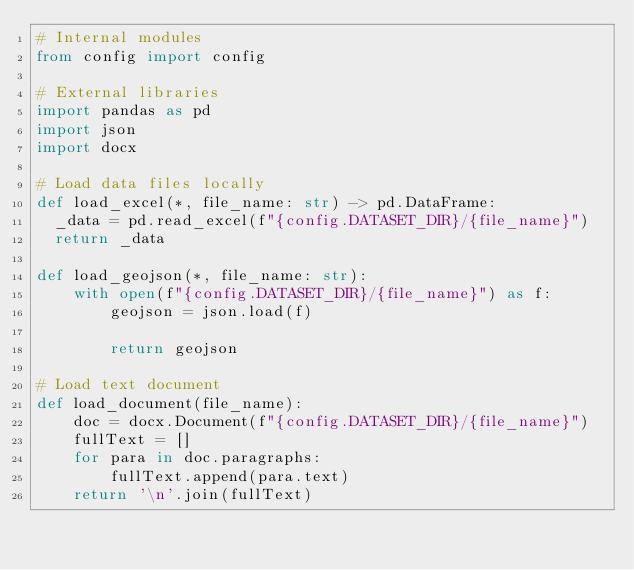<code> <loc_0><loc_0><loc_500><loc_500><_Python_># Internal modules
from config import config

# External libraries
import pandas as pd
import json
import docx

# Load data files locally
def load_excel(*, file_name: str) -> pd.DataFrame:
	_data = pd.read_excel(f"{config.DATASET_DIR}/{file_name}")
	return _data

def load_geojson(*, file_name: str):
    with open(f"{config.DATASET_DIR}/{file_name}") as f:
        geojson = json.load(f)

        return geojson

# Load text document
def load_document(file_name):
    doc = docx.Document(f"{config.DATASET_DIR}/{file_name}")
    fullText = []
    for para in doc.paragraphs:
        fullText.append(para.text)
    return '\n'.join(fullText)



</code> 